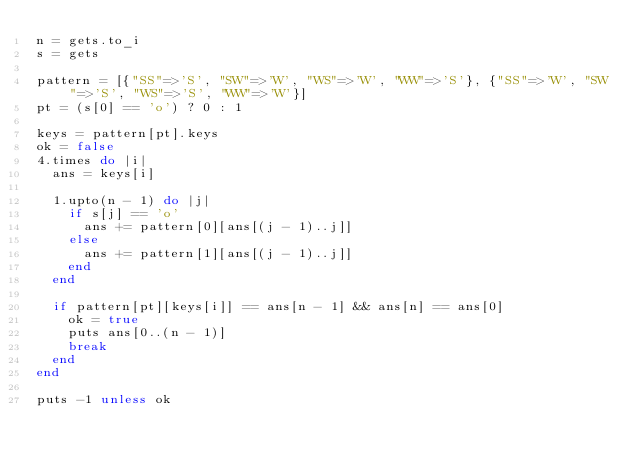<code> <loc_0><loc_0><loc_500><loc_500><_Ruby_>n = gets.to_i
s = gets

pattern = [{"SS"=>'S', "SW"=>'W', "WS"=>'W', "WW"=>'S'}, {"SS"=>'W', "SW"=>'S', "WS"=>'S', "WW"=>'W'}]
pt = (s[0] == 'o') ? 0 : 1

keys = pattern[pt].keys
ok = false
4.times do |i|
  ans = keys[i]

  1.upto(n - 1) do |j|
    if s[j] == 'o'
      ans += pattern[0][ans[(j - 1)..j]]
    else
      ans += pattern[1][ans[(j - 1)..j]]
    end
  end

  if pattern[pt][keys[i]] == ans[n - 1] && ans[n] == ans[0]
    ok = true
    puts ans[0..(n - 1)]
    break
  end
end

puts -1 unless ok</code> 